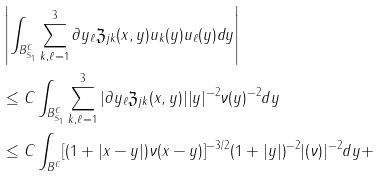Convert formula to latex. <formula><loc_0><loc_0><loc_500><loc_500>& \left | \int _ { B ^ { C } _ { S _ { 1 } } } \sum ^ { 3 } _ { k , \ell = 1 } \partial y _ { \ell } \mathfrak Z _ { j k } ( x , y ) u _ { k } ( y ) u _ { \ell } ( y ) d y \right | \\ & \leq C \int _ { B ^ { C } _ { S _ { 1 } } } \sum ^ { 3 } _ { k , \ell = 1 } | \partial y _ { \ell } \mathfrak Z _ { j k } ( x , y ) | | y | ^ { - 2 } \nu ( y ) ^ { - 2 } d y \\ & \leq C \int _ { B ^ { C } } [ ( 1 + | x - y | ) \nu ( x - y ) ] ^ { - 3 / 2 } ( 1 + | y | ) ^ { - 2 } | ( \nu ) | ^ { - 2 } d y +</formula> 